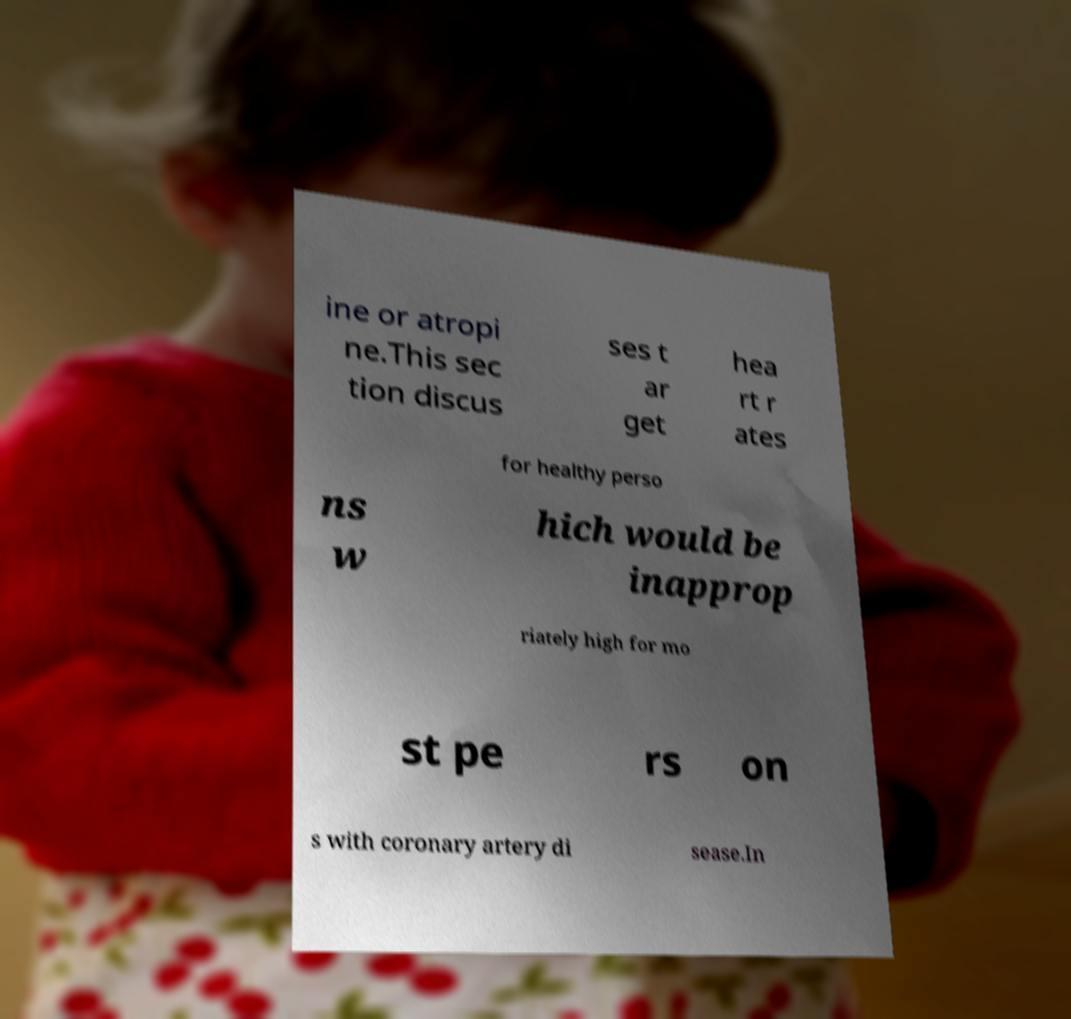Could you extract and type out the text from this image? ine or atropi ne.This sec tion discus ses t ar get hea rt r ates for healthy perso ns w hich would be inapprop riately high for mo st pe rs on s with coronary artery di sease.In 